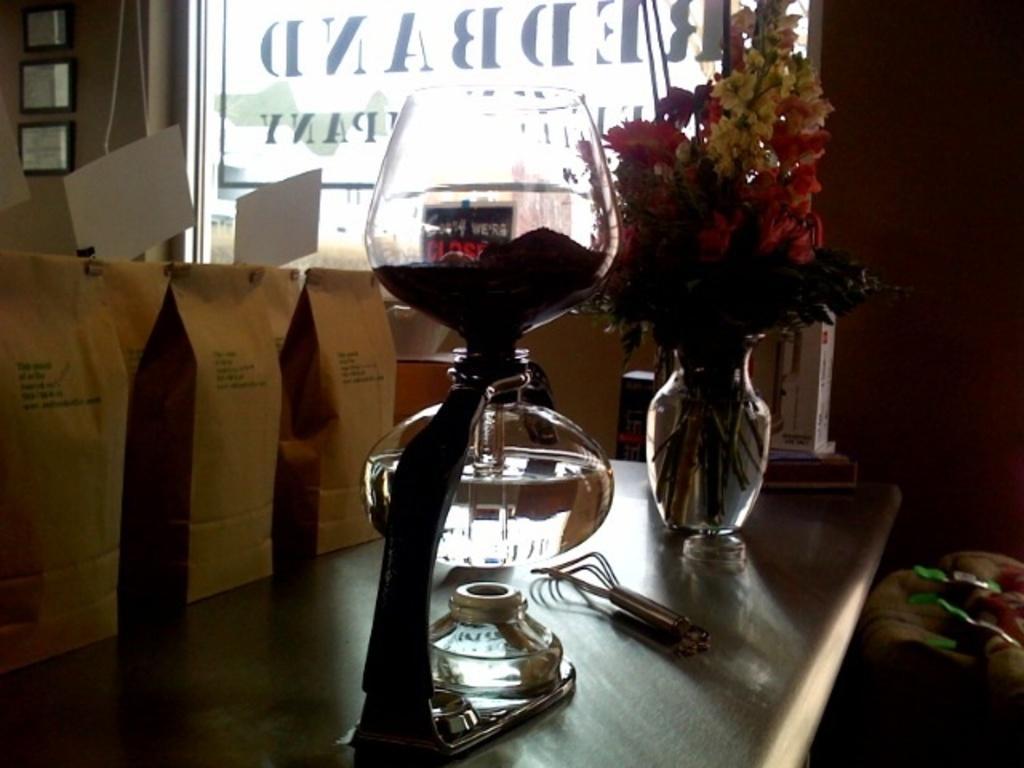How would you summarize this image in a sentence or two? This picture shows a glass and a flower pot on the table and we see paper bags on the side and we see glass and photo frames on the wall. 